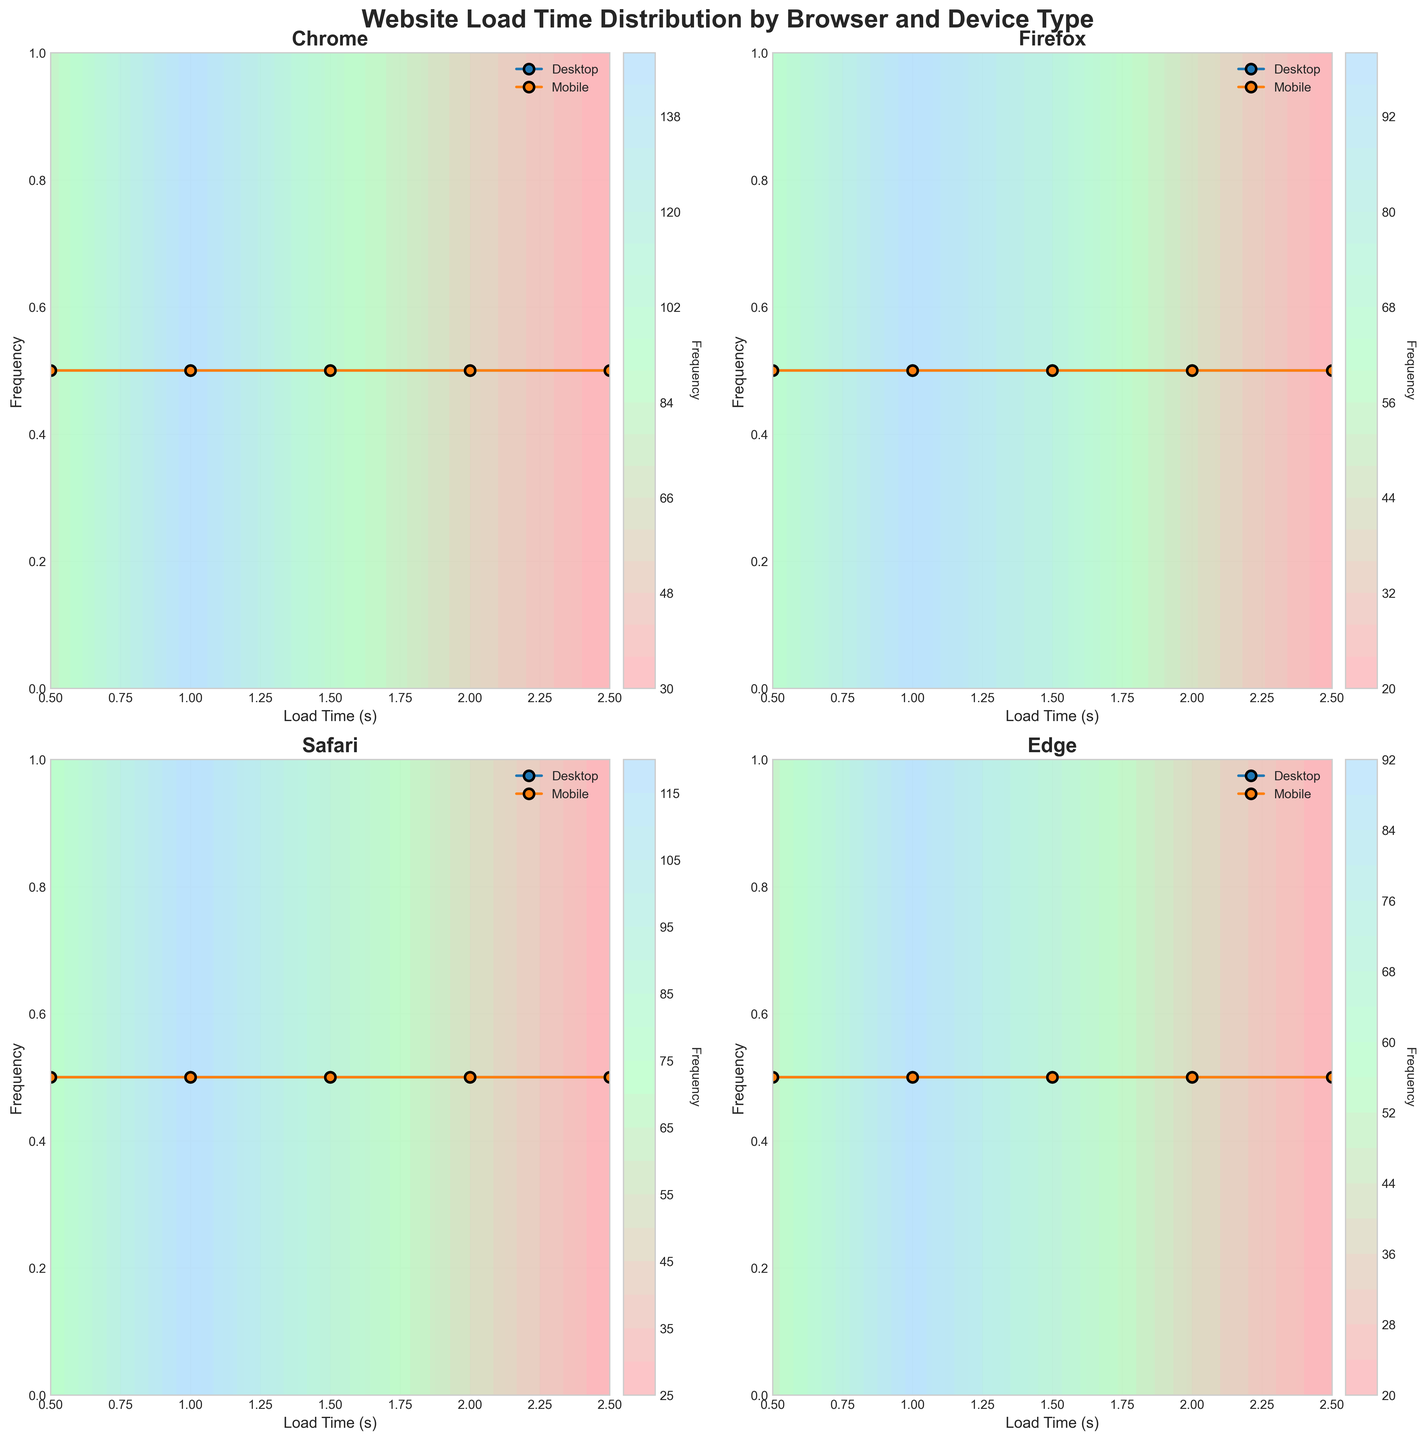What is the title of the plot? The title is displayed at the top of the plot, serving as a summary of what the plot represents. It is written in a larger and bold font for emphasis.
Answer: Website Load Time Distribution by Browser and Device Type How many subplots are there in the main plot? The plot has a grid layout, with each cell representing a subset of the data. By counting the number of cells in the grid, we determine the number of subplots.
Answer: 4 Which browser has the highest frequency for desktop load time of 0.5 seconds? Look at the contour plots for each browser and observe the frequency values for a load time of 0.5 seconds on desktop devices.
Answer: Chrome Which device type for Firefox has a higher frequency at a load time of 1.5 seconds? Compare the frequencies for the load time of 1.5 seconds between desktop and mobile devices for Firefox, as indicated by the contour colors and values.
Answer: Desktop What is the color range representing the frequency in the contour plot? The contour plot uses a custom colormap developed from a gradient of three colors. By observing the plot legend, we can identify the color range used.
Answer: Shades of pink, green, and blue Which browser shows the most consistent loading times across all device types? Consistent loading times would be indicated by similar frequency patterns across both desktop and mobile devices in the contour plots for a given browser.
Answer: Chrome What is the trend in load time for Edge on mobile devices? Examine the contour lines and points for Edge in the mobile device subplot to observe how frequency values change with varying load times.
Answer: Decreases as load time increases Compare the frequencies of load times between Chrome on desktop and Firefox on mobile for a load time of 1.0 seconds. Which is higher? Extract the frequencies for the load time of 1.0 seconds from the respective subplots and compare them.
Answer: Chrome on desktop Which browser has the lowest frequency for any device type at a load time of 2.5 seconds? Identify the lowest frequency values for a load time of 2.5 seconds across all subplots and note which browser they correspond to.
Answer: Safari on desktop Are load times generally faster on desktop or mobile for Safari? Compare the frequency patterns and contour plot distributions for both device types under the Safari browser subplots.
Answer: Desktop 